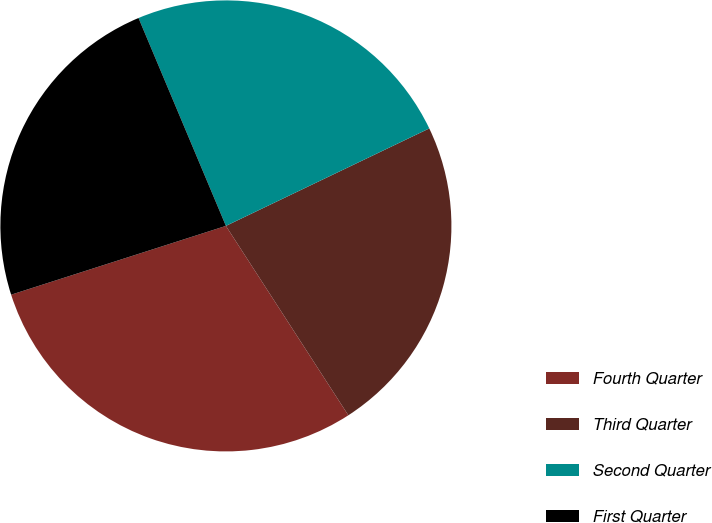Convert chart. <chart><loc_0><loc_0><loc_500><loc_500><pie_chart><fcel>Fourth Quarter<fcel>Third Quarter<fcel>Second Quarter<fcel>First Quarter<nl><fcel>29.2%<fcel>22.98%<fcel>24.22%<fcel>23.6%<nl></chart> 